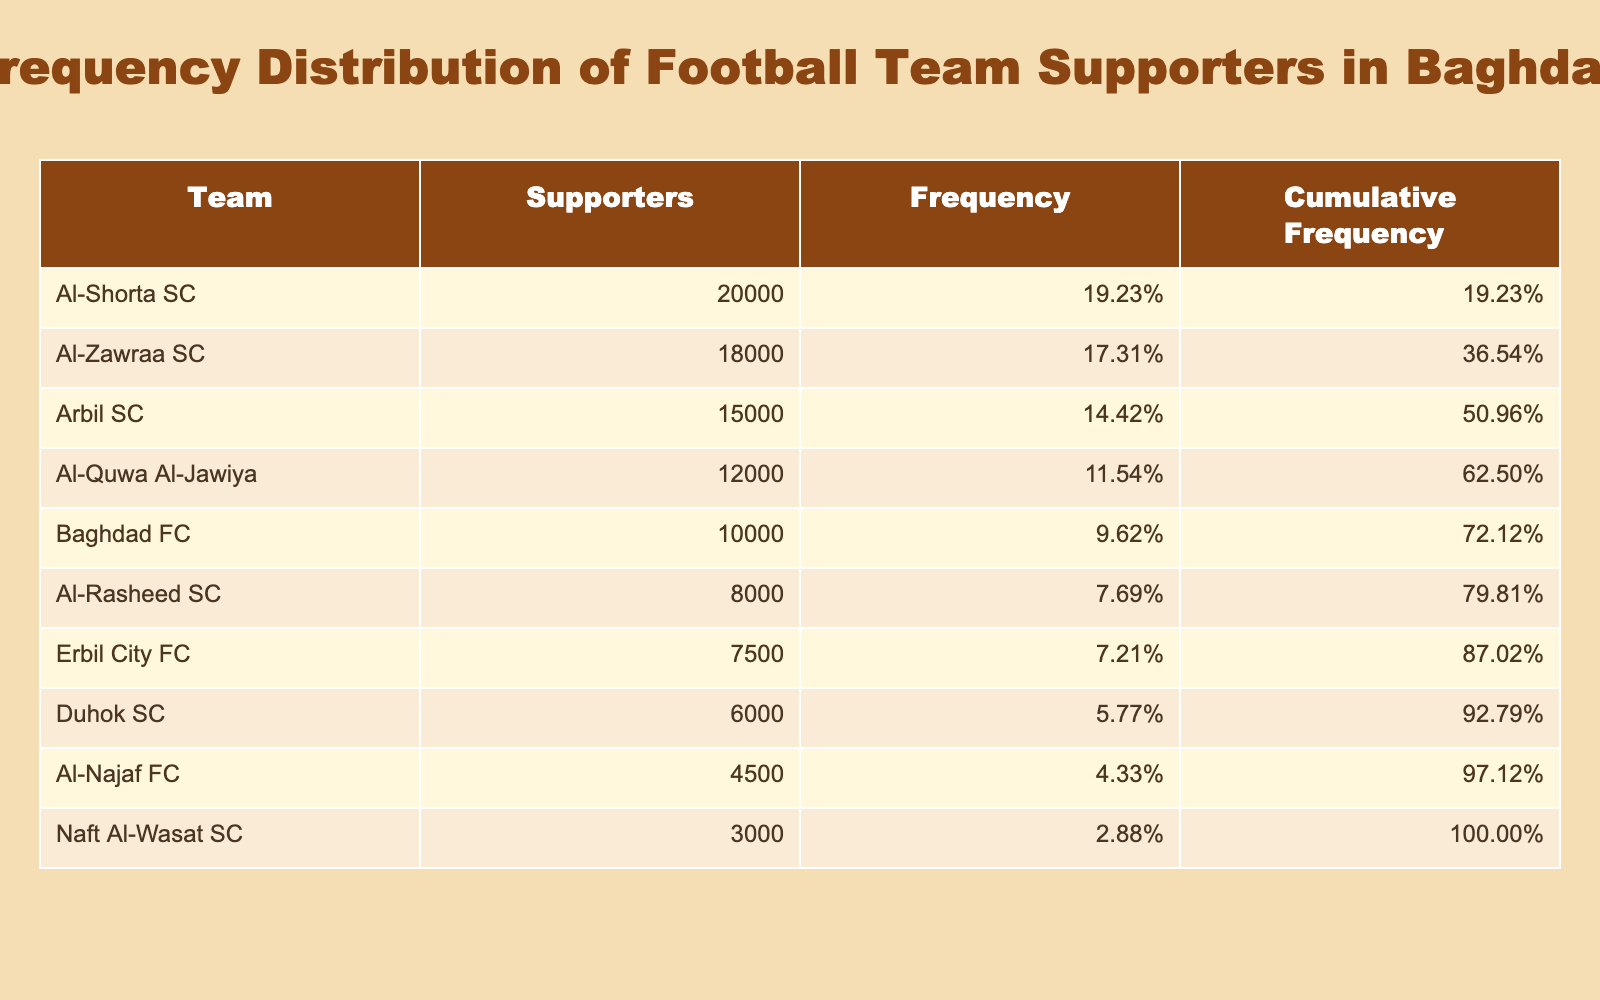What is the total number of supporters for all teams combined? To find the total number of supporters, we sum up the "Number of Supporters" column: 20000 + 18000 + 15000 + 12000 + 10000 + 8000 + 7500 + 6000 + 4500 + 3000 = 100000.
Answer: 100000 Which team has the highest number of supporters? The team with the highest number of supporters is Al-Shorta SC as it has 20000 supporters, which is the largest value in the "Number of Supporters" column.
Answer: Al-Shorta SC What percentage of the total supporters does Baghdad FC represent? First, we find Baghdad FC's number of supporters: 10000. Then we take its percentage of the total supporters: (10000 / 100000) * 100 = 10%.
Answer: 10% How many more supporters does Al-Zawraa SC have compared to Al-Najaf FC? Al-Zawraa SC has 18000 supporters and Al-Najaf FC has 4500 supporters. The difference is 18000 - 4500 = 13500.
Answer: 13500 Is Al-Rasheed SC's number of supporters greater than 10000? Al-Rasheed SC has 8000 supporters, which is less than 10000. Therefore, the statement is false.
Answer: No What is the cumulative frequency of Arbil SC? To find the cumulative frequency of Arbil SC, we need to add the frequencies of all teams up to Arbil SC: Al-Shorta SC (0.20) + Al-Zawraa SC (0.18) + Arbil SC (0.15) = 0.53. We use the total supporters to convert to a percentage: 0.53 * 100 = 53%.
Answer: 53% Which team has the least number of supporters? The team with the least number of supporters is Naft Al-Wasat SC, which has only 3000 supporters, the smallest number in the "Number of Supporters" column.
Answer: Naft Al-Wasat SC What is the average number of supporters across all teams? To find the average, we sum all the supporters (100000) and divide by the number of teams (10): 100000 / 10 = 10000.
Answer: 10000 How many teams have more than 7000 supporters? The teams that have more than 7000 supporters are Al-Shorta SC, Al-Zawraa SC, Arbil SC, Al-Quwa Al-Jawiya, Baghdad FC, Al-Rasheed SC, and Erbil City FC. That gives a total of 6 teams.
Answer: 6 